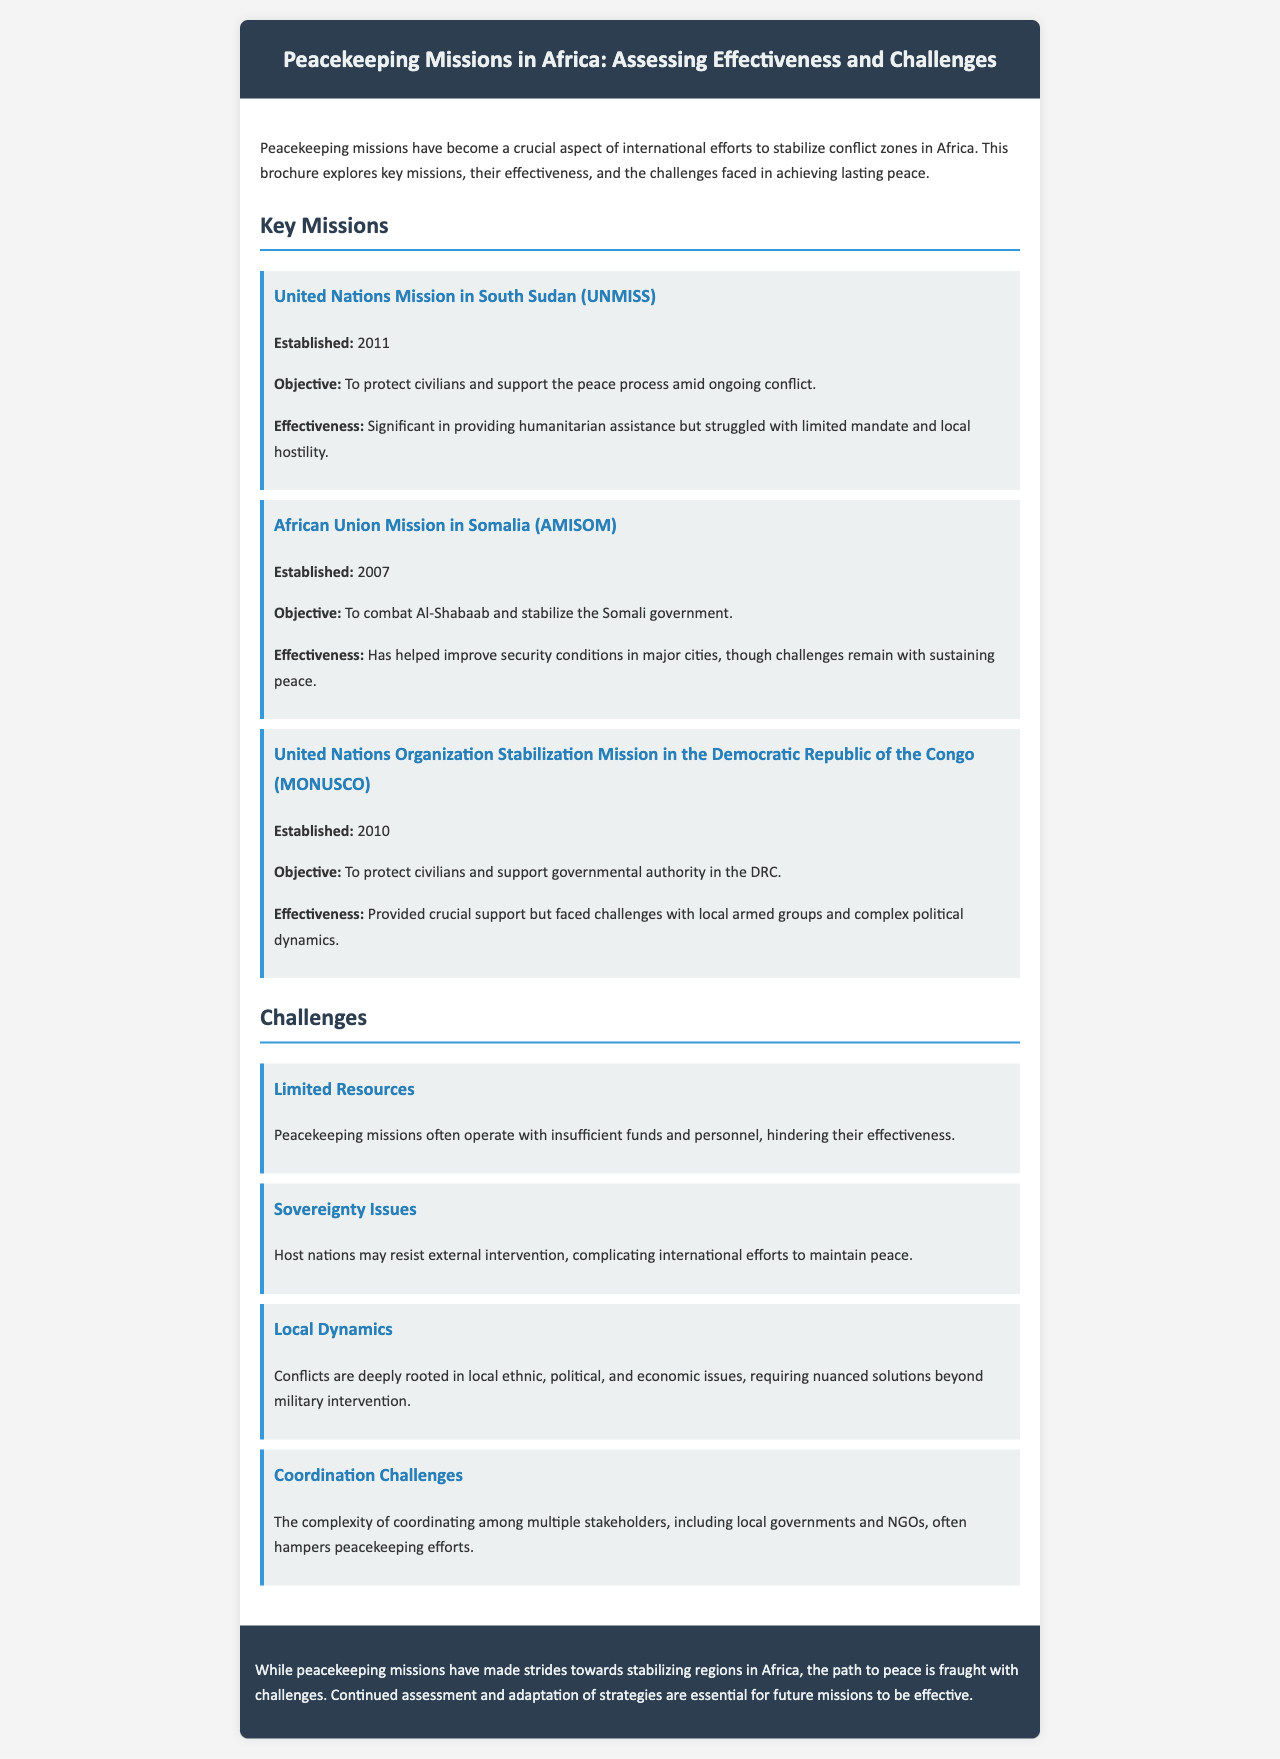what is the establishment year of UNMISS? The establishment year is explicitly stated in the document under the mission section.
Answer: 2011 what is the objective of the African Union Mission in Somalia? The objective is highlighted under the mission description for AMISOM in the document.
Answer: To combat Al-Shabaab and stabilize the Somali government how many challenges are mentioned in the document? The document lists four specific challenges under the challenges section.
Answer: Four what is a significant effectiveness noted for MONUSCO? This effectiveness is described in the text regarding the crucial support provided by the mission.
Answer: Provided crucial support what is one of the sovereignty issues mentioned? The document discusses issues related to host nations resisting external intervention.
Answer: Host nations may resist external intervention what year was AMISOM established? The year is provided alongside the mission details for AMISOM in the brochure.
Answer: 2007 what type of document is this? The overall structure and content provide clarity on the document's purpose.
Answer: Brochure what is one coordination challenge mentioned? The specific challenge is stated within the challenges section discussing coordination among stakeholders.
Answer: Coordination among multiple stakeholders 